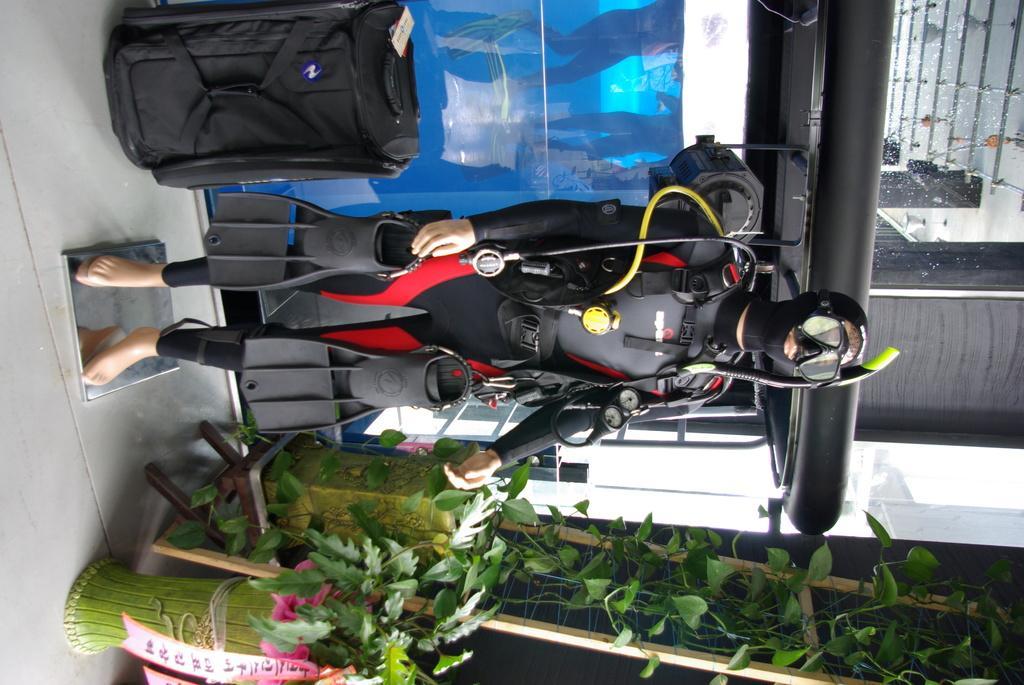Describe this image in one or two sentences. In this image in the center there is one manque and that manque is wearing swimming costume, and holding some shoes. At the bottom there are some flower pots and plants, and on the top of the image there is one bag. On the right side there is one pipe and glass window, on the left side there is a floor. 